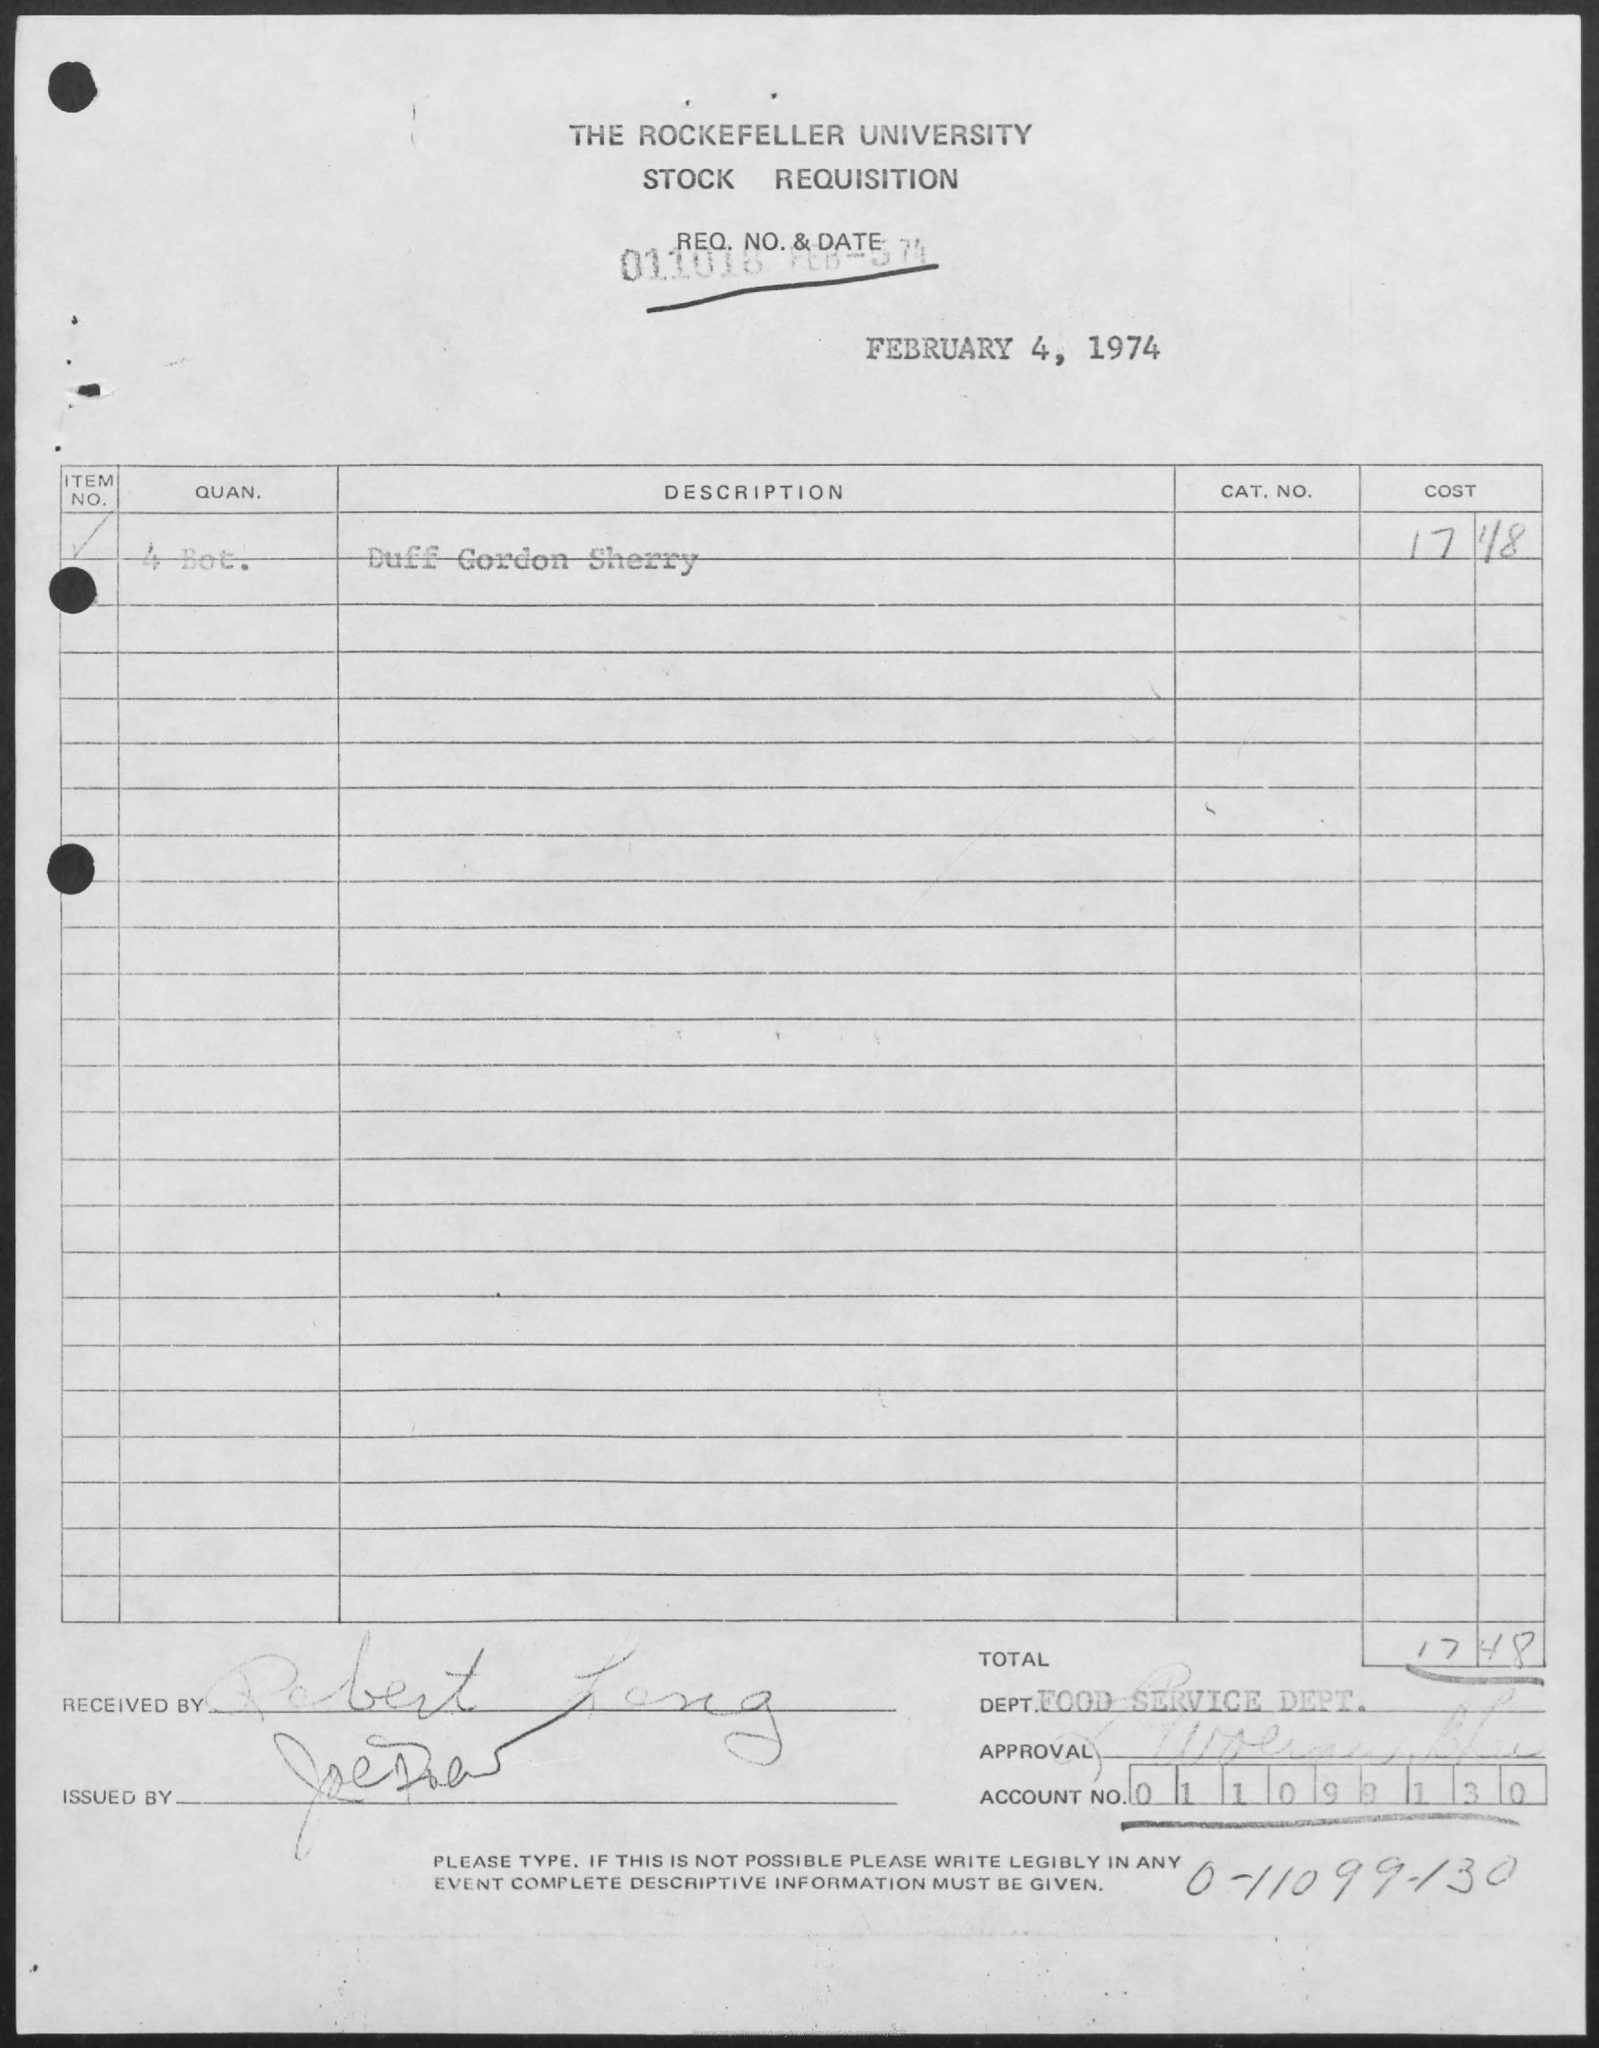Draw attention to some important aspects in this diagram. The account number is "011099130" and it includes several digits. The total is 17 and 48. The Department Name is the Food Service Department. The text written on the letterhead is "The Rockefeller University Stock Requisition. The Memorandum was dated on February 4, 1974. 